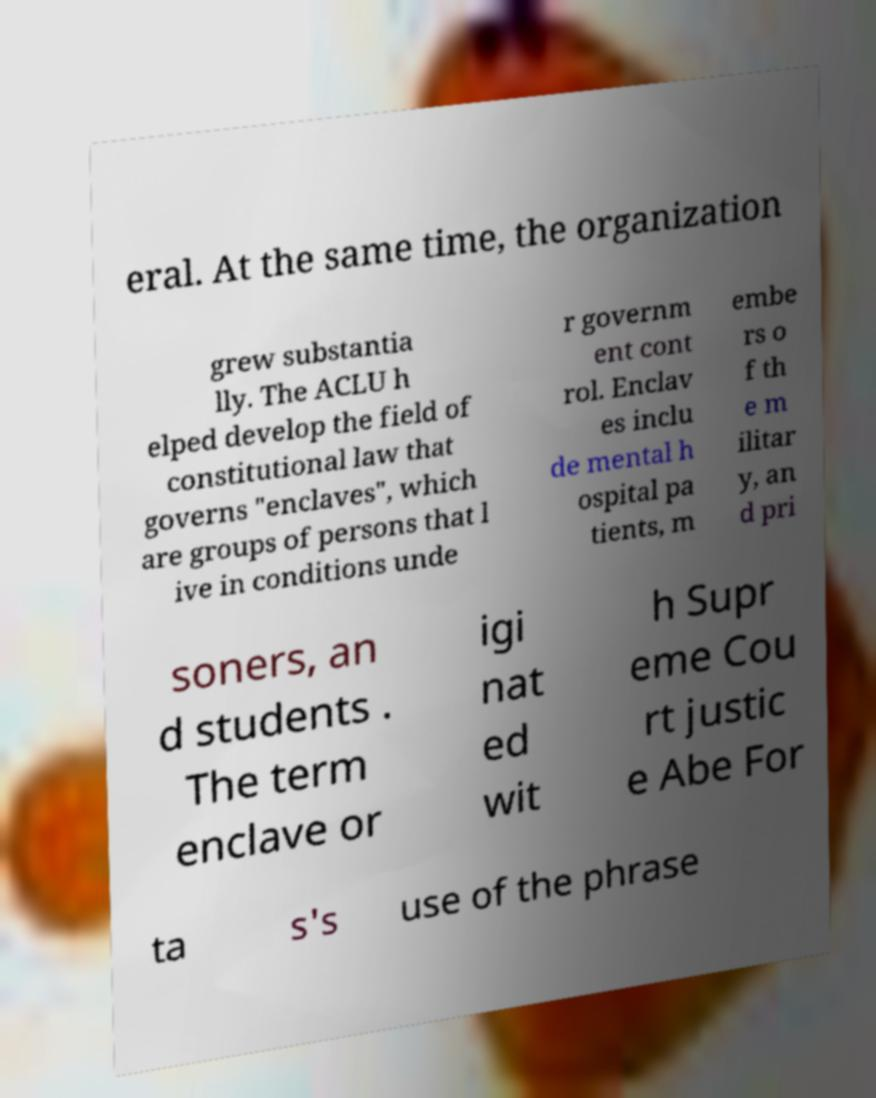Please identify and transcribe the text found in this image. eral. At the same time, the organization grew substantia lly. The ACLU h elped develop the field of constitutional law that governs "enclaves", which are groups of persons that l ive in conditions unde r governm ent cont rol. Enclav es inclu de mental h ospital pa tients, m embe rs o f th e m ilitar y, an d pri soners, an d students . The term enclave or igi nat ed wit h Supr eme Cou rt justic e Abe For ta s's use of the phrase 